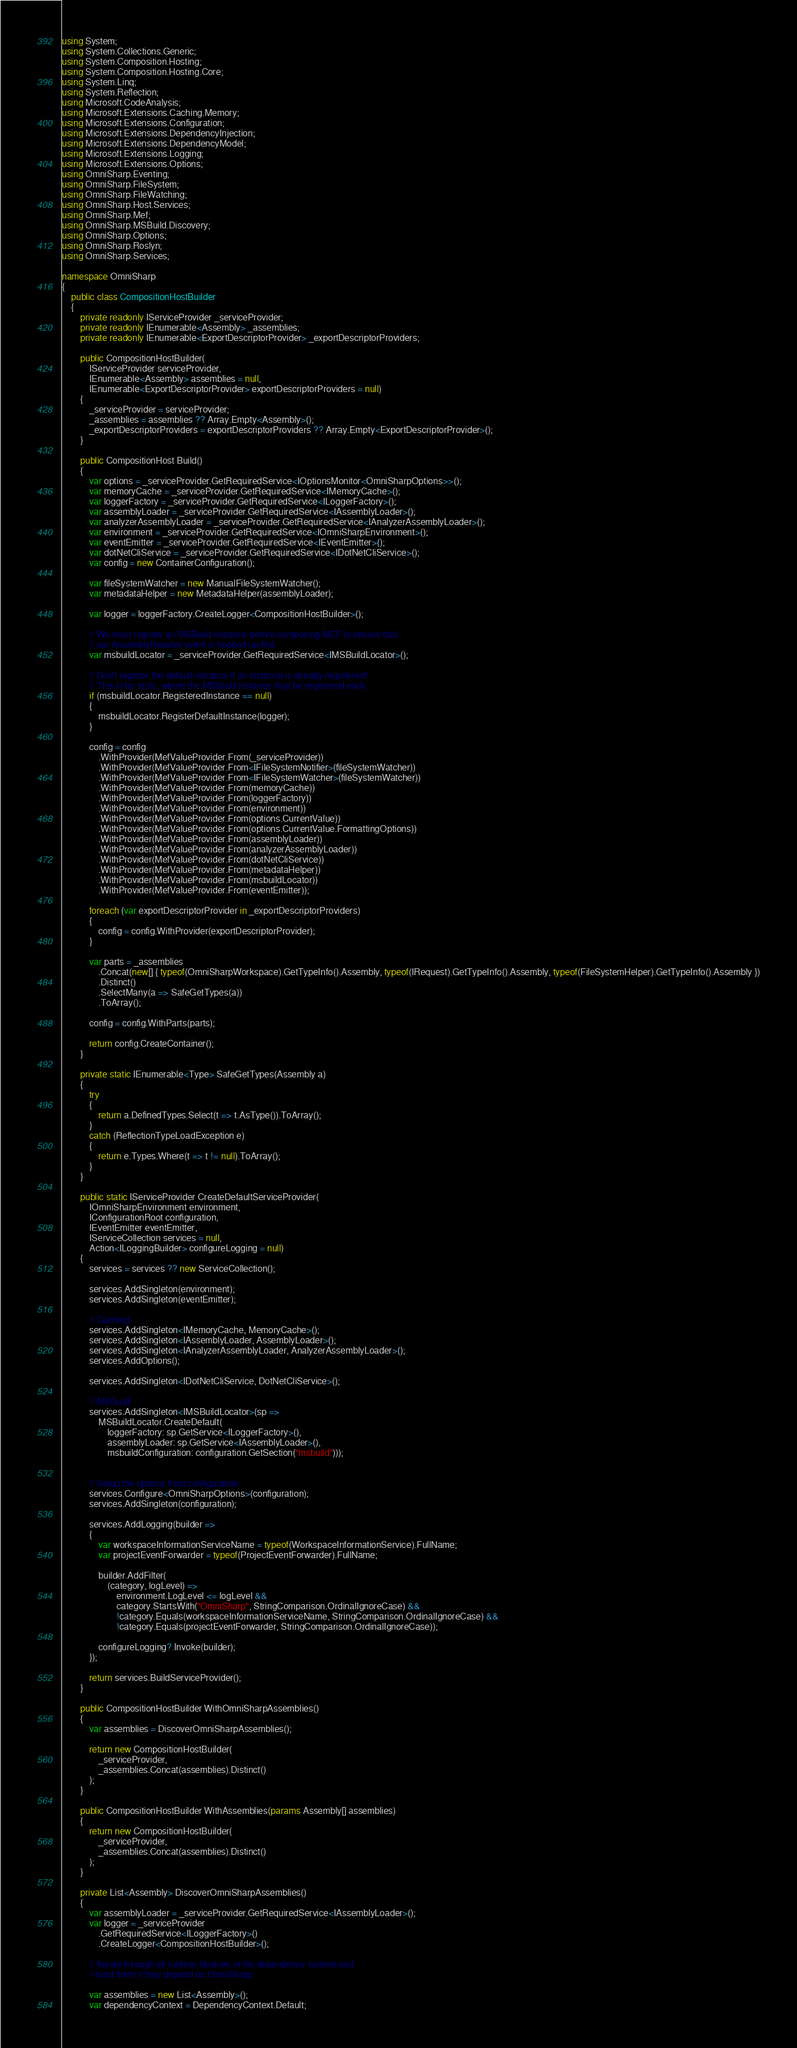<code> <loc_0><loc_0><loc_500><loc_500><_C#_>using System;
using System.Collections.Generic;
using System.Composition.Hosting;
using System.Composition.Hosting.Core;
using System.Linq;
using System.Reflection;
using Microsoft.CodeAnalysis;
using Microsoft.Extensions.Caching.Memory;
using Microsoft.Extensions.Configuration;
using Microsoft.Extensions.DependencyInjection;
using Microsoft.Extensions.DependencyModel;
using Microsoft.Extensions.Logging;
using Microsoft.Extensions.Options;
using OmniSharp.Eventing;
using OmniSharp.FileSystem;
using OmniSharp.FileWatching;
using OmniSharp.Host.Services;
using OmniSharp.Mef;
using OmniSharp.MSBuild.Discovery;
using OmniSharp.Options;
using OmniSharp.Roslyn;
using OmniSharp.Services;

namespace OmniSharp
{
    public class CompositionHostBuilder
    {
        private readonly IServiceProvider _serviceProvider;
        private readonly IEnumerable<Assembly> _assemblies;
        private readonly IEnumerable<ExportDescriptorProvider> _exportDescriptorProviders;

        public CompositionHostBuilder(
            IServiceProvider serviceProvider,
            IEnumerable<Assembly> assemblies = null,
            IEnumerable<ExportDescriptorProvider> exportDescriptorProviders = null)
        {
            _serviceProvider = serviceProvider;
            _assemblies = assemblies ?? Array.Empty<Assembly>();
            _exportDescriptorProviders = exportDescriptorProviders ?? Array.Empty<ExportDescriptorProvider>();
        }

        public CompositionHost Build()
        {
            var options = _serviceProvider.GetRequiredService<IOptionsMonitor<OmniSharpOptions>>();
            var memoryCache = _serviceProvider.GetRequiredService<IMemoryCache>();
            var loggerFactory = _serviceProvider.GetRequiredService<ILoggerFactory>();
            var assemblyLoader = _serviceProvider.GetRequiredService<IAssemblyLoader>();
            var analyzerAssemblyLoader = _serviceProvider.GetRequiredService<IAnalyzerAssemblyLoader>();
            var environment = _serviceProvider.GetRequiredService<IOmniSharpEnvironment>();
            var eventEmitter = _serviceProvider.GetRequiredService<IEventEmitter>();
            var dotNetCliService = _serviceProvider.GetRequiredService<IDotNetCliService>();
            var config = new ContainerConfiguration();

            var fileSystemWatcher = new ManualFileSystemWatcher();
            var metadataHelper = new MetadataHelper(assemblyLoader);

            var logger = loggerFactory.CreateLogger<CompositionHostBuilder>();

            // We must register an MSBuild instance before composing MEF to ensure that
            // our AssemblyResolve event is hooked up first.
            var msbuildLocator = _serviceProvider.GetRequiredService<IMSBuildLocator>();

            // Don't register the default instance if an instance is already registered!
            // This is for tests, where the MSBuild instance may be registered early.
            if (msbuildLocator.RegisteredInstance == null)
            {
                msbuildLocator.RegisterDefaultInstance(logger);
            }

            config = config
                .WithProvider(MefValueProvider.From(_serviceProvider))
                .WithProvider(MefValueProvider.From<IFileSystemNotifier>(fileSystemWatcher))
                .WithProvider(MefValueProvider.From<IFileSystemWatcher>(fileSystemWatcher))
                .WithProvider(MefValueProvider.From(memoryCache))
                .WithProvider(MefValueProvider.From(loggerFactory))
                .WithProvider(MefValueProvider.From(environment))
                .WithProvider(MefValueProvider.From(options.CurrentValue))
                .WithProvider(MefValueProvider.From(options.CurrentValue.FormattingOptions))
                .WithProvider(MefValueProvider.From(assemblyLoader))
                .WithProvider(MefValueProvider.From(analyzerAssemblyLoader))
                .WithProvider(MefValueProvider.From(dotNetCliService))
                .WithProvider(MefValueProvider.From(metadataHelper))
                .WithProvider(MefValueProvider.From(msbuildLocator))
                .WithProvider(MefValueProvider.From(eventEmitter));

            foreach (var exportDescriptorProvider in _exportDescriptorProviders)
            {
                config = config.WithProvider(exportDescriptorProvider);
            }

            var parts = _assemblies
                .Concat(new[] { typeof(OmniSharpWorkspace).GetTypeInfo().Assembly, typeof(IRequest).GetTypeInfo().Assembly, typeof(FileSystemHelper).GetTypeInfo().Assembly })
                .Distinct()
                .SelectMany(a => SafeGetTypes(a))
                .ToArray();

            config = config.WithParts(parts);

            return config.CreateContainer();
        }

        private static IEnumerable<Type> SafeGetTypes(Assembly a)
        {
            try
            {
                return a.DefinedTypes.Select(t => t.AsType()).ToArray();
            }
            catch (ReflectionTypeLoadException e)
            {
                return e.Types.Where(t => t != null).ToArray();
            }
        }

        public static IServiceProvider CreateDefaultServiceProvider(
            IOmniSharpEnvironment environment,
            IConfigurationRoot configuration,
            IEventEmitter eventEmitter,
            IServiceCollection services = null,
            Action<ILoggingBuilder> configureLogging = null)
        {
            services = services ?? new ServiceCollection();

            services.AddSingleton(environment);
            services.AddSingleton(eventEmitter);

            // Caching
            services.AddSingleton<IMemoryCache, MemoryCache>();
            services.AddSingleton<IAssemblyLoader, AssemblyLoader>();
            services.AddSingleton<IAnalyzerAssemblyLoader, AnalyzerAssemblyLoader>();
            services.AddOptions();

            services.AddSingleton<IDotNetCliService, DotNetCliService>();

            // MSBuild
            services.AddSingleton<IMSBuildLocator>(sp =>
                MSBuildLocator.CreateDefault(
                    loggerFactory: sp.GetService<ILoggerFactory>(),
                    assemblyLoader: sp.GetService<IAssemblyLoader>(),
                    msbuildConfiguration: configuration.GetSection("msbuild")));


            // Setup the options from configuration
            services.Configure<OmniSharpOptions>(configuration);
            services.AddSingleton(configuration);

            services.AddLogging(builder =>
            {
                var workspaceInformationServiceName = typeof(WorkspaceInformationService).FullName;
                var projectEventForwarder = typeof(ProjectEventForwarder).FullName;

                builder.AddFilter(
                    (category, logLevel) =>
                        environment.LogLevel <= logLevel &&
                        category.StartsWith("OmniSharp", StringComparison.OrdinalIgnoreCase) &&
                        !category.Equals(workspaceInformationServiceName, StringComparison.OrdinalIgnoreCase) &&
                        !category.Equals(projectEventForwarder, StringComparison.OrdinalIgnoreCase));

                configureLogging?.Invoke(builder);
            });

            return services.BuildServiceProvider();
        }

        public CompositionHostBuilder WithOmniSharpAssemblies()
        {
            var assemblies = DiscoverOmniSharpAssemblies();

            return new CompositionHostBuilder(
                _serviceProvider,
                _assemblies.Concat(assemblies).Distinct()
            );
        }

        public CompositionHostBuilder WithAssemblies(params Assembly[] assemblies)
        {
            return new CompositionHostBuilder(
                _serviceProvider,
                _assemblies.Concat(assemblies).Distinct()
            );
        }

        private List<Assembly> DiscoverOmniSharpAssemblies()
        {
            var assemblyLoader = _serviceProvider.GetRequiredService<IAssemblyLoader>();
            var logger = _serviceProvider
                .GetRequiredService<ILoggerFactory>()
                .CreateLogger<CompositionHostBuilder>();

            // Iterate through all runtime libraries in the dependency context and
            // load them if they depend on OmniSharp.

            var assemblies = new List<Assembly>();
            var dependencyContext = DependencyContext.Default;
</code> 